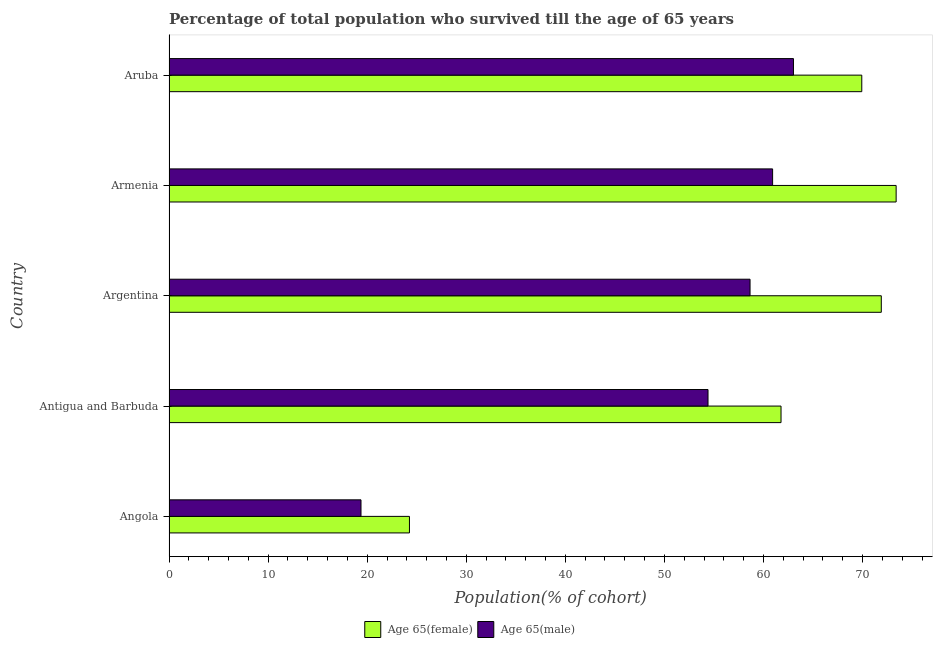How many groups of bars are there?
Ensure brevity in your answer.  5. Are the number of bars on each tick of the Y-axis equal?
Provide a short and direct response. Yes. How many bars are there on the 1st tick from the top?
Ensure brevity in your answer.  2. What is the label of the 5th group of bars from the top?
Provide a succinct answer. Angola. In how many cases, is the number of bars for a given country not equal to the number of legend labels?
Your answer should be very brief. 0. What is the percentage of female population who survived till age of 65 in Armenia?
Provide a succinct answer. 73.38. Across all countries, what is the maximum percentage of male population who survived till age of 65?
Give a very brief answer. 63.02. Across all countries, what is the minimum percentage of male population who survived till age of 65?
Provide a succinct answer. 19.38. In which country was the percentage of female population who survived till age of 65 maximum?
Make the answer very short. Armenia. In which country was the percentage of female population who survived till age of 65 minimum?
Provide a short and direct response. Angola. What is the total percentage of male population who survived till age of 65 in the graph?
Keep it short and to the point. 256.35. What is the difference between the percentage of male population who survived till age of 65 in Armenia and that in Aruba?
Offer a terse response. -2.1. What is the difference between the percentage of male population who survived till age of 65 in Armenia and the percentage of female population who survived till age of 65 in Aruba?
Provide a short and direct response. -9. What is the average percentage of male population who survived till age of 65 per country?
Ensure brevity in your answer.  51.27. What is the difference between the percentage of male population who survived till age of 65 and percentage of female population who survived till age of 65 in Antigua and Barbuda?
Offer a very short reply. -7.37. In how many countries, is the percentage of male population who survived till age of 65 greater than 58 %?
Ensure brevity in your answer.  3. What is the ratio of the percentage of female population who survived till age of 65 in Antigua and Barbuda to that in Argentina?
Offer a terse response. 0.86. What is the difference between the highest and the second highest percentage of female population who survived till age of 65?
Provide a short and direct response. 1.5. What is the difference between the highest and the lowest percentage of female population who survived till age of 65?
Give a very brief answer. 49.12. What does the 2nd bar from the top in Antigua and Barbuda represents?
Keep it short and to the point. Age 65(female). What does the 1st bar from the bottom in Antigua and Barbuda represents?
Offer a terse response. Age 65(female). Are all the bars in the graph horizontal?
Make the answer very short. Yes. How many countries are there in the graph?
Make the answer very short. 5. What is the difference between two consecutive major ticks on the X-axis?
Provide a succinct answer. 10. Are the values on the major ticks of X-axis written in scientific E-notation?
Offer a very short reply. No. Does the graph contain any zero values?
Your response must be concise. No. Does the graph contain grids?
Make the answer very short. No. How many legend labels are there?
Make the answer very short. 2. What is the title of the graph?
Your answer should be very brief. Percentage of total population who survived till the age of 65 years. What is the label or title of the X-axis?
Ensure brevity in your answer.  Population(% of cohort). What is the Population(% of cohort) of Age 65(female) in Angola?
Provide a succinct answer. 24.27. What is the Population(% of cohort) of Age 65(male) in Angola?
Make the answer very short. 19.38. What is the Population(% of cohort) of Age 65(female) in Antigua and Barbuda?
Make the answer very short. 61.77. What is the Population(% of cohort) of Age 65(male) in Antigua and Barbuda?
Keep it short and to the point. 54.4. What is the Population(% of cohort) of Age 65(female) in Argentina?
Your answer should be compact. 71.88. What is the Population(% of cohort) of Age 65(male) in Argentina?
Give a very brief answer. 58.64. What is the Population(% of cohort) of Age 65(female) in Armenia?
Your answer should be compact. 73.38. What is the Population(% of cohort) of Age 65(male) in Armenia?
Offer a very short reply. 60.92. What is the Population(% of cohort) in Age 65(female) in Aruba?
Make the answer very short. 69.92. What is the Population(% of cohort) of Age 65(male) in Aruba?
Make the answer very short. 63.02. Across all countries, what is the maximum Population(% of cohort) of Age 65(female)?
Offer a terse response. 73.38. Across all countries, what is the maximum Population(% of cohort) in Age 65(male)?
Provide a short and direct response. 63.02. Across all countries, what is the minimum Population(% of cohort) of Age 65(female)?
Provide a short and direct response. 24.27. Across all countries, what is the minimum Population(% of cohort) in Age 65(male)?
Offer a terse response. 19.38. What is the total Population(% of cohort) in Age 65(female) in the graph?
Give a very brief answer. 301.22. What is the total Population(% of cohort) in Age 65(male) in the graph?
Keep it short and to the point. 256.35. What is the difference between the Population(% of cohort) in Age 65(female) in Angola and that in Antigua and Barbuda?
Provide a succinct answer. -37.5. What is the difference between the Population(% of cohort) of Age 65(male) in Angola and that in Antigua and Barbuda?
Your response must be concise. -35.02. What is the difference between the Population(% of cohort) in Age 65(female) in Angola and that in Argentina?
Provide a succinct answer. -47.62. What is the difference between the Population(% of cohort) in Age 65(male) in Angola and that in Argentina?
Offer a very short reply. -39.26. What is the difference between the Population(% of cohort) in Age 65(female) in Angola and that in Armenia?
Your answer should be compact. -49.12. What is the difference between the Population(% of cohort) of Age 65(male) in Angola and that in Armenia?
Ensure brevity in your answer.  -41.54. What is the difference between the Population(% of cohort) of Age 65(female) in Angola and that in Aruba?
Make the answer very short. -45.65. What is the difference between the Population(% of cohort) of Age 65(male) in Angola and that in Aruba?
Your answer should be very brief. -43.64. What is the difference between the Population(% of cohort) in Age 65(female) in Antigua and Barbuda and that in Argentina?
Your response must be concise. -10.12. What is the difference between the Population(% of cohort) in Age 65(male) in Antigua and Barbuda and that in Argentina?
Keep it short and to the point. -4.24. What is the difference between the Population(% of cohort) in Age 65(female) in Antigua and Barbuda and that in Armenia?
Offer a terse response. -11.62. What is the difference between the Population(% of cohort) in Age 65(male) in Antigua and Barbuda and that in Armenia?
Offer a terse response. -6.52. What is the difference between the Population(% of cohort) of Age 65(female) in Antigua and Barbuda and that in Aruba?
Ensure brevity in your answer.  -8.15. What is the difference between the Population(% of cohort) of Age 65(male) in Antigua and Barbuda and that in Aruba?
Offer a terse response. -8.62. What is the difference between the Population(% of cohort) in Age 65(female) in Argentina and that in Armenia?
Your answer should be compact. -1.5. What is the difference between the Population(% of cohort) of Age 65(male) in Argentina and that in Armenia?
Offer a terse response. -2.28. What is the difference between the Population(% of cohort) of Age 65(female) in Argentina and that in Aruba?
Provide a succinct answer. 1.97. What is the difference between the Population(% of cohort) of Age 65(male) in Argentina and that in Aruba?
Your answer should be compact. -4.38. What is the difference between the Population(% of cohort) in Age 65(female) in Armenia and that in Aruba?
Make the answer very short. 3.47. What is the difference between the Population(% of cohort) in Age 65(male) in Armenia and that in Aruba?
Offer a terse response. -2.1. What is the difference between the Population(% of cohort) in Age 65(female) in Angola and the Population(% of cohort) in Age 65(male) in Antigua and Barbuda?
Your answer should be compact. -30.13. What is the difference between the Population(% of cohort) in Age 65(female) in Angola and the Population(% of cohort) in Age 65(male) in Argentina?
Provide a short and direct response. -34.37. What is the difference between the Population(% of cohort) of Age 65(female) in Angola and the Population(% of cohort) of Age 65(male) in Armenia?
Keep it short and to the point. -36.65. What is the difference between the Population(% of cohort) in Age 65(female) in Angola and the Population(% of cohort) in Age 65(male) in Aruba?
Provide a succinct answer. -38.75. What is the difference between the Population(% of cohort) in Age 65(female) in Antigua and Barbuda and the Population(% of cohort) in Age 65(male) in Argentina?
Provide a short and direct response. 3.13. What is the difference between the Population(% of cohort) of Age 65(female) in Antigua and Barbuda and the Population(% of cohort) of Age 65(male) in Armenia?
Keep it short and to the point. 0.85. What is the difference between the Population(% of cohort) of Age 65(female) in Antigua and Barbuda and the Population(% of cohort) of Age 65(male) in Aruba?
Keep it short and to the point. -1.25. What is the difference between the Population(% of cohort) of Age 65(female) in Argentina and the Population(% of cohort) of Age 65(male) in Armenia?
Your answer should be very brief. 10.97. What is the difference between the Population(% of cohort) of Age 65(female) in Argentina and the Population(% of cohort) of Age 65(male) in Aruba?
Keep it short and to the point. 8.86. What is the difference between the Population(% of cohort) of Age 65(female) in Armenia and the Population(% of cohort) of Age 65(male) in Aruba?
Give a very brief answer. 10.36. What is the average Population(% of cohort) in Age 65(female) per country?
Your answer should be very brief. 60.24. What is the average Population(% of cohort) of Age 65(male) per country?
Your response must be concise. 51.27. What is the difference between the Population(% of cohort) of Age 65(female) and Population(% of cohort) of Age 65(male) in Angola?
Offer a terse response. 4.89. What is the difference between the Population(% of cohort) in Age 65(female) and Population(% of cohort) in Age 65(male) in Antigua and Barbuda?
Provide a succinct answer. 7.37. What is the difference between the Population(% of cohort) in Age 65(female) and Population(% of cohort) in Age 65(male) in Argentina?
Ensure brevity in your answer.  13.24. What is the difference between the Population(% of cohort) in Age 65(female) and Population(% of cohort) in Age 65(male) in Armenia?
Make the answer very short. 12.47. What is the difference between the Population(% of cohort) in Age 65(female) and Population(% of cohort) in Age 65(male) in Aruba?
Ensure brevity in your answer.  6.89. What is the ratio of the Population(% of cohort) in Age 65(female) in Angola to that in Antigua and Barbuda?
Your answer should be compact. 0.39. What is the ratio of the Population(% of cohort) in Age 65(male) in Angola to that in Antigua and Barbuda?
Make the answer very short. 0.36. What is the ratio of the Population(% of cohort) of Age 65(female) in Angola to that in Argentina?
Your answer should be compact. 0.34. What is the ratio of the Population(% of cohort) of Age 65(male) in Angola to that in Argentina?
Provide a short and direct response. 0.33. What is the ratio of the Population(% of cohort) of Age 65(female) in Angola to that in Armenia?
Provide a short and direct response. 0.33. What is the ratio of the Population(% of cohort) in Age 65(male) in Angola to that in Armenia?
Make the answer very short. 0.32. What is the ratio of the Population(% of cohort) of Age 65(female) in Angola to that in Aruba?
Provide a short and direct response. 0.35. What is the ratio of the Population(% of cohort) of Age 65(male) in Angola to that in Aruba?
Give a very brief answer. 0.31. What is the ratio of the Population(% of cohort) of Age 65(female) in Antigua and Barbuda to that in Argentina?
Offer a very short reply. 0.86. What is the ratio of the Population(% of cohort) of Age 65(male) in Antigua and Barbuda to that in Argentina?
Offer a terse response. 0.93. What is the ratio of the Population(% of cohort) in Age 65(female) in Antigua and Barbuda to that in Armenia?
Offer a terse response. 0.84. What is the ratio of the Population(% of cohort) of Age 65(male) in Antigua and Barbuda to that in Armenia?
Provide a succinct answer. 0.89. What is the ratio of the Population(% of cohort) of Age 65(female) in Antigua and Barbuda to that in Aruba?
Make the answer very short. 0.88. What is the ratio of the Population(% of cohort) in Age 65(male) in Antigua and Barbuda to that in Aruba?
Give a very brief answer. 0.86. What is the ratio of the Population(% of cohort) of Age 65(female) in Argentina to that in Armenia?
Ensure brevity in your answer.  0.98. What is the ratio of the Population(% of cohort) in Age 65(male) in Argentina to that in Armenia?
Offer a terse response. 0.96. What is the ratio of the Population(% of cohort) of Age 65(female) in Argentina to that in Aruba?
Offer a terse response. 1.03. What is the ratio of the Population(% of cohort) of Age 65(male) in Argentina to that in Aruba?
Your answer should be compact. 0.93. What is the ratio of the Population(% of cohort) in Age 65(female) in Armenia to that in Aruba?
Keep it short and to the point. 1.05. What is the ratio of the Population(% of cohort) in Age 65(male) in Armenia to that in Aruba?
Provide a succinct answer. 0.97. What is the difference between the highest and the second highest Population(% of cohort) of Age 65(female)?
Give a very brief answer. 1.5. What is the difference between the highest and the second highest Population(% of cohort) of Age 65(male)?
Your answer should be compact. 2.1. What is the difference between the highest and the lowest Population(% of cohort) of Age 65(female)?
Give a very brief answer. 49.12. What is the difference between the highest and the lowest Population(% of cohort) of Age 65(male)?
Your response must be concise. 43.64. 